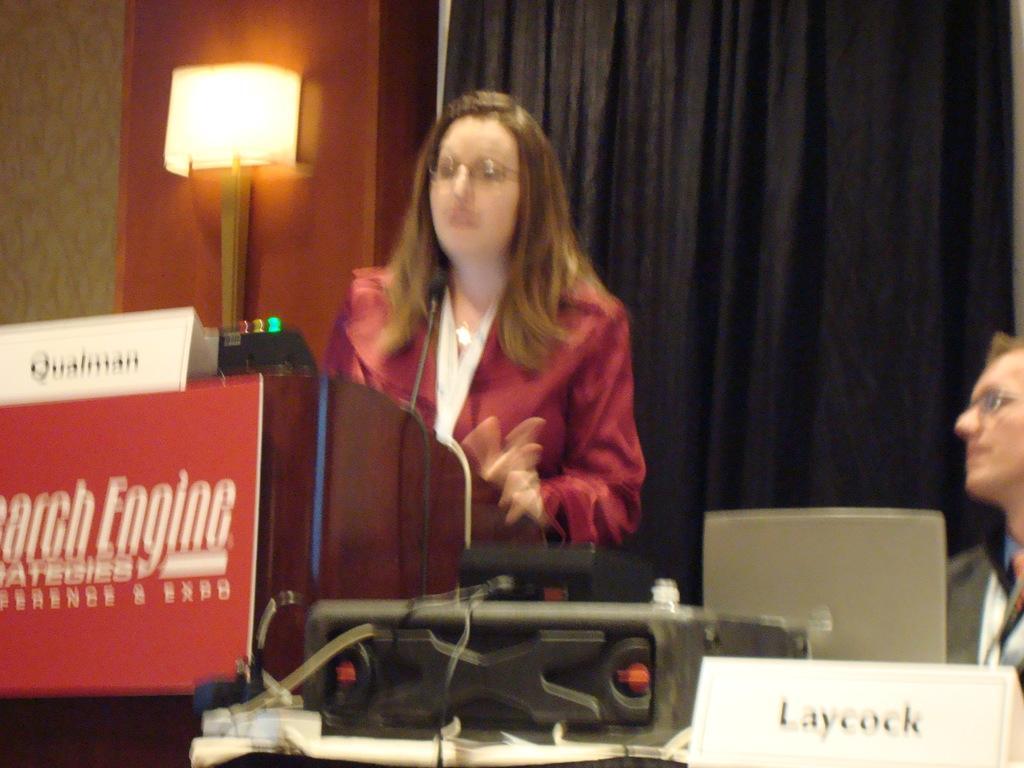In one or two sentences, can you explain what this image depicts? In this image I can see two people. One person standing in-front of the podium and there are boards attached to the podium. In-front of an another person I can see the laptop, black color object and the board. In the background I can see the light and the black color curtain. 